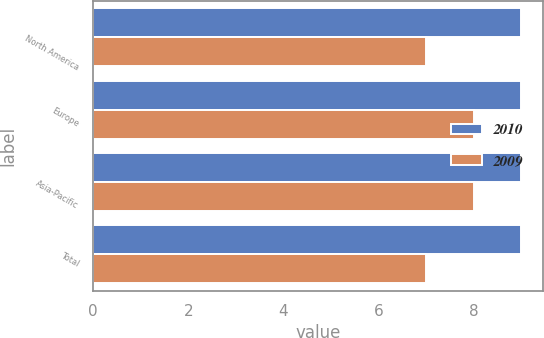Convert chart to OTSL. <chart><loc_0><loc_0><loc_500><loc_500><stacked_bar_chart><ecel><fcel>North America<fcel>Europe<fcel>Asia-Pacific<fcel>Total<nl><fcel>2010<fcel>9<fcel>9<fcel>9<fcel>9<nl><fcel>2009<fcel>7<fcel>8<fcel>8<fcel>7<nl></chart> 